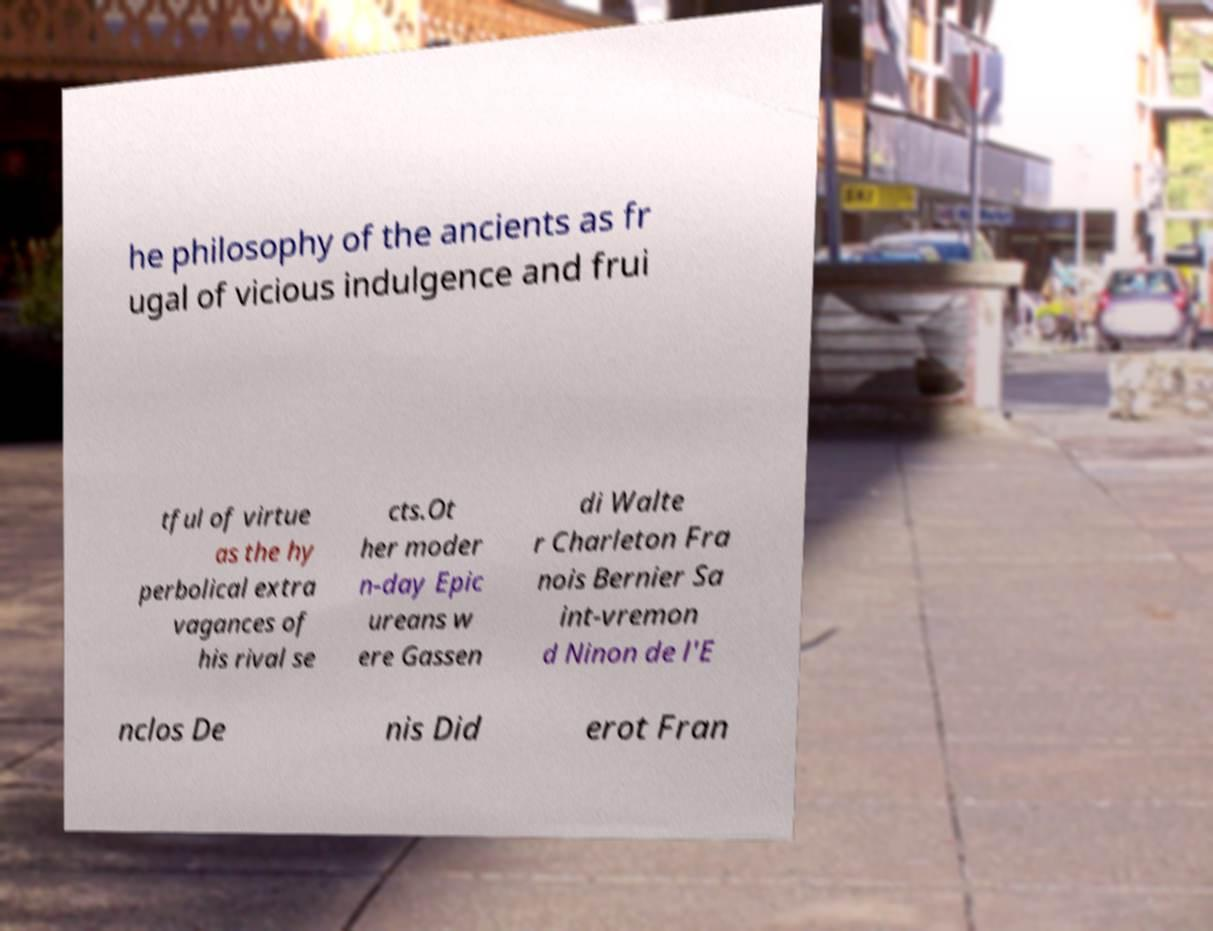There's text embedded in this image that I need extracted. Can you transcribe it verbatim? he philosophy of the ancients as fr ugal of vicious indulgence and frui tful of virtue as the hy perbolical extra vagances of his rival se cts.Ot her moder n-day Epic ureans w ere Gassen di Walte r Charleton Fra nois Bernier Sa int-vremon d Ninon de l'E nclos De nis Did erot Fran 